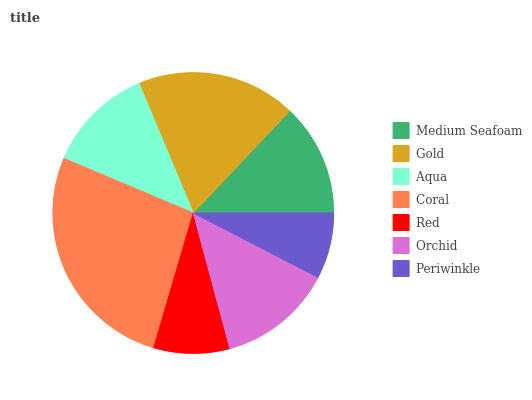Is Periwinkle the minimum?
Answer yes or no. Yes. Is Coral the maximum?
Answer yes or no. Yes. Is Gold the minimum?
Answer yes or no. No. Is Gold the maximum?
Answer yes or no. No. Is Gold greater than Medium Seafoam?
Answer yes or no. Yes. Is Medium Seafoam less than Gold?
Answer yes or no. Yes. Is Medium Seafoam greater than Gold?
Answer yes or no. No. Is Gold less than Medium Seafoam?
Answer yes or no. No. Is Medium Seafoam the high median?
Answer yes or no. Yes. Is Medium Seafoam the low median?
Answer yes or no. Yes. Is Aqua the high median?
Answer yes or no. No. Is Coral the low median?
Answer yes or no. No. 